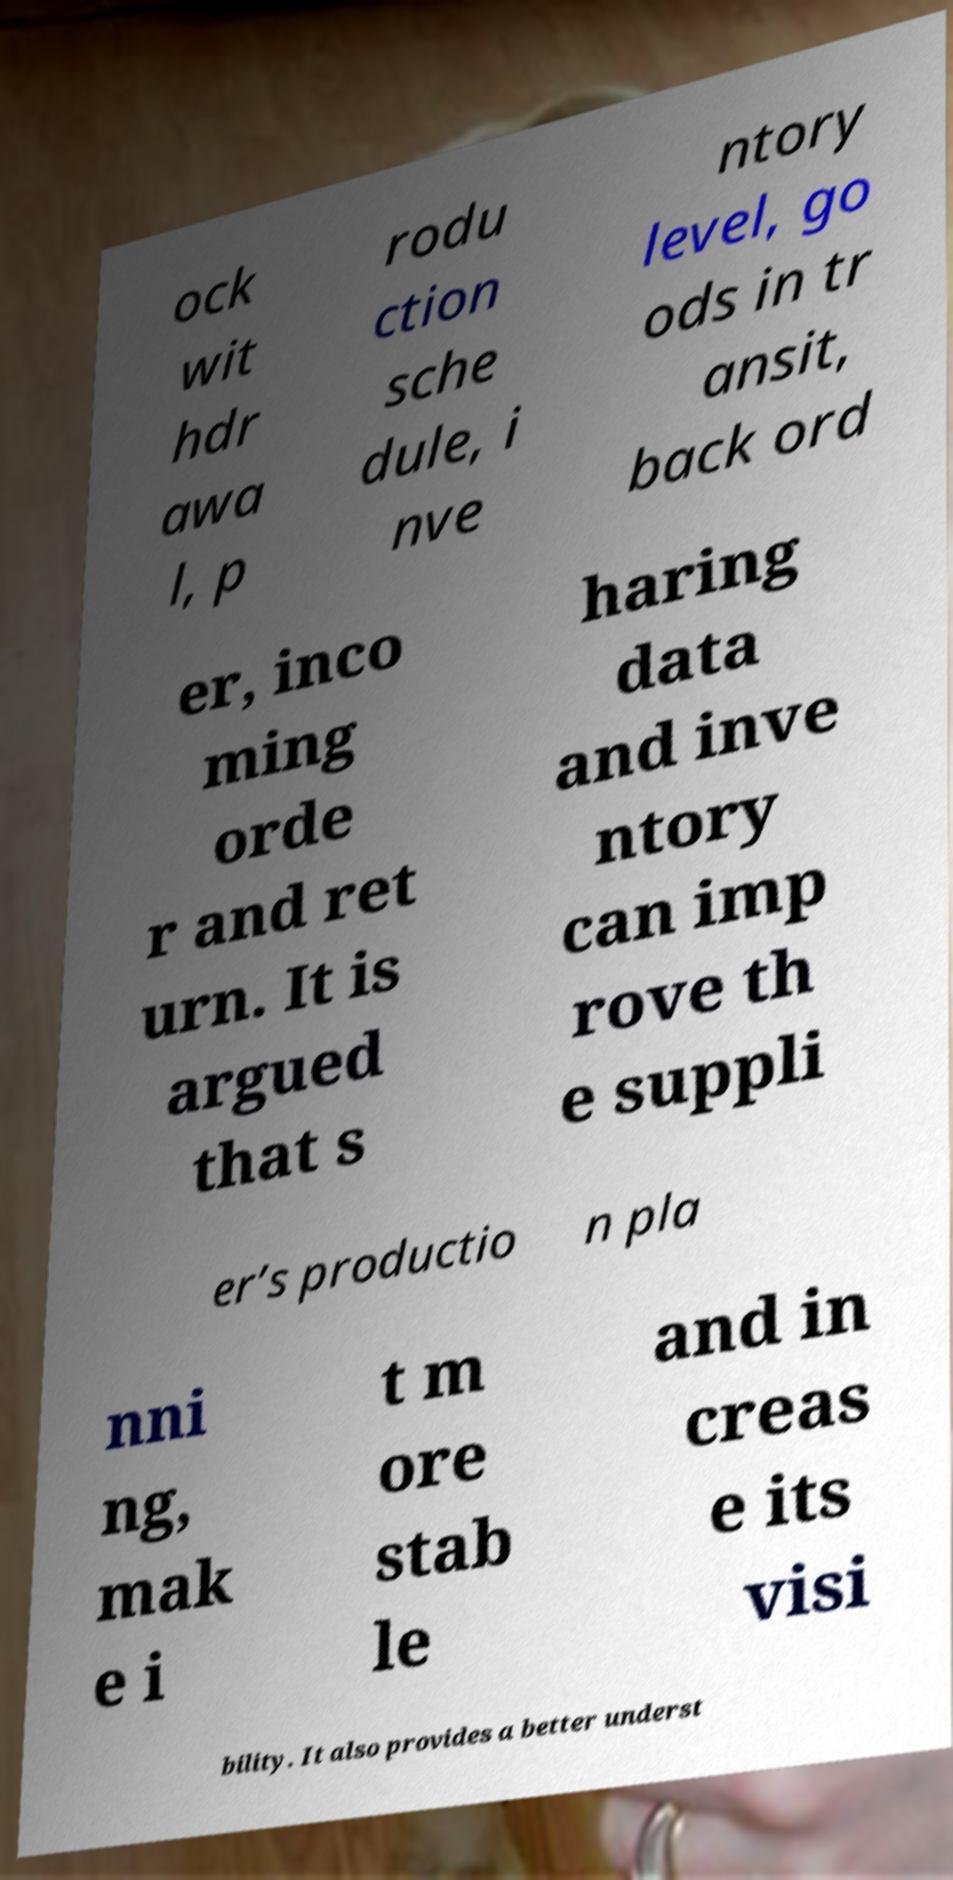Could you extract and type out the text from this image? ock wit hdr awa l, p rodu ction sche dule, i nve ntory level, go ods in tr ansit, back ord er, inco ming orde r and ret urn. It is argued that s haring data and inve ntory can imp rove th e suppli er’s productio n pla nni ng, mak e i t m ore stab le and in creas e its visi bility. It also provides a better underst 